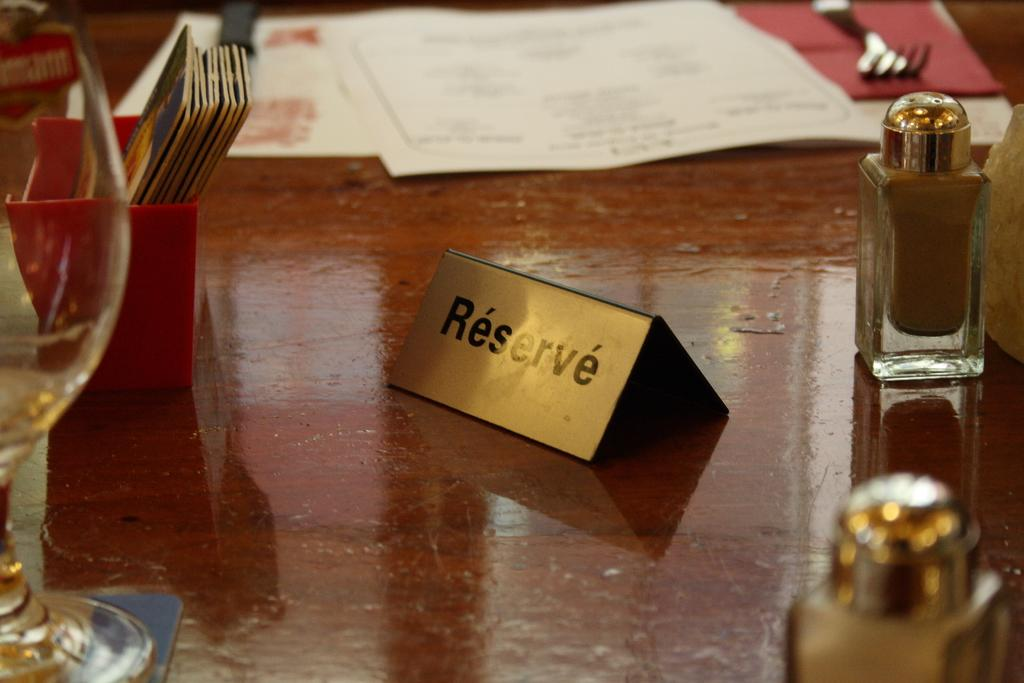Provide a one-sentence caption for the provided image. A small gold sign indicates that a table is not available because it has been reserved. 